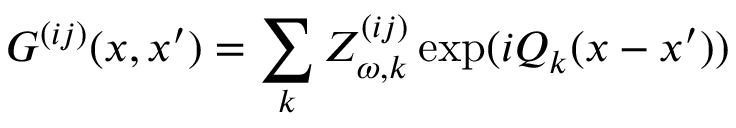<formula> <loc_0><loc_0><loc_500><loc_500>G ^ { ( i j ) } ( x , x ^ { \prime } ) = \sum _ { k } Z _ { \omega , k } ^ { ( i j ) } \exp ( i Q _ { k } ( x - x ^ { \prime } ) )</formula> 